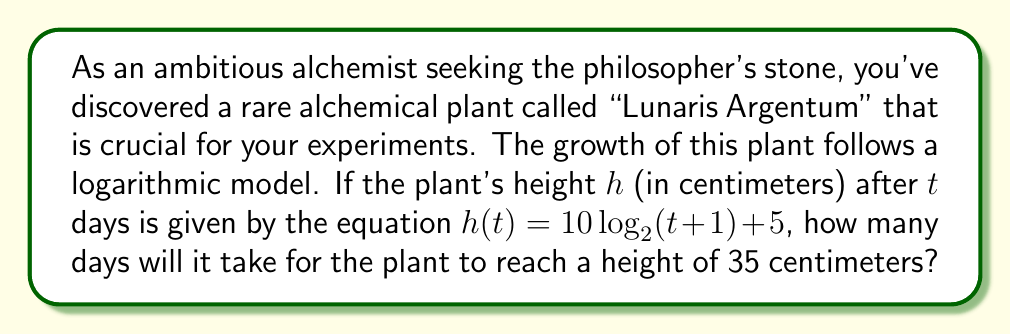Can you solve this math problem? To solve this problem, we need to use the given logarithmic model and solve for $t$ when $h(t) = 35$. Let's approach this step-by-step:

1) We start with the equation: $h(t) = 10 \log_2(t+1) + 5$

2) We want to find $t$ when $h(t) = 35$, so we substitute this:
   $35 = 10 \log_2(t+1) + 5$

3) Subtract 5 from both sides:
   $30 = 10 \log_2(t+1)$

4) Divide both sides by 10:
   $3 = \log_2(t+1)$

5) To solve for $t$, we need to apply the inverse function of $\log_2$, which is $2^x$:
   $2^3 = t+1$

6) Simplify:
   $8 = t+1$

7) Subtract 1 from both sides:
   $7 = t$

Therefore, it will take 7 days for the Lunaris Argentum plant to reach a height of 35 centimeters.
Answer: 7 days 